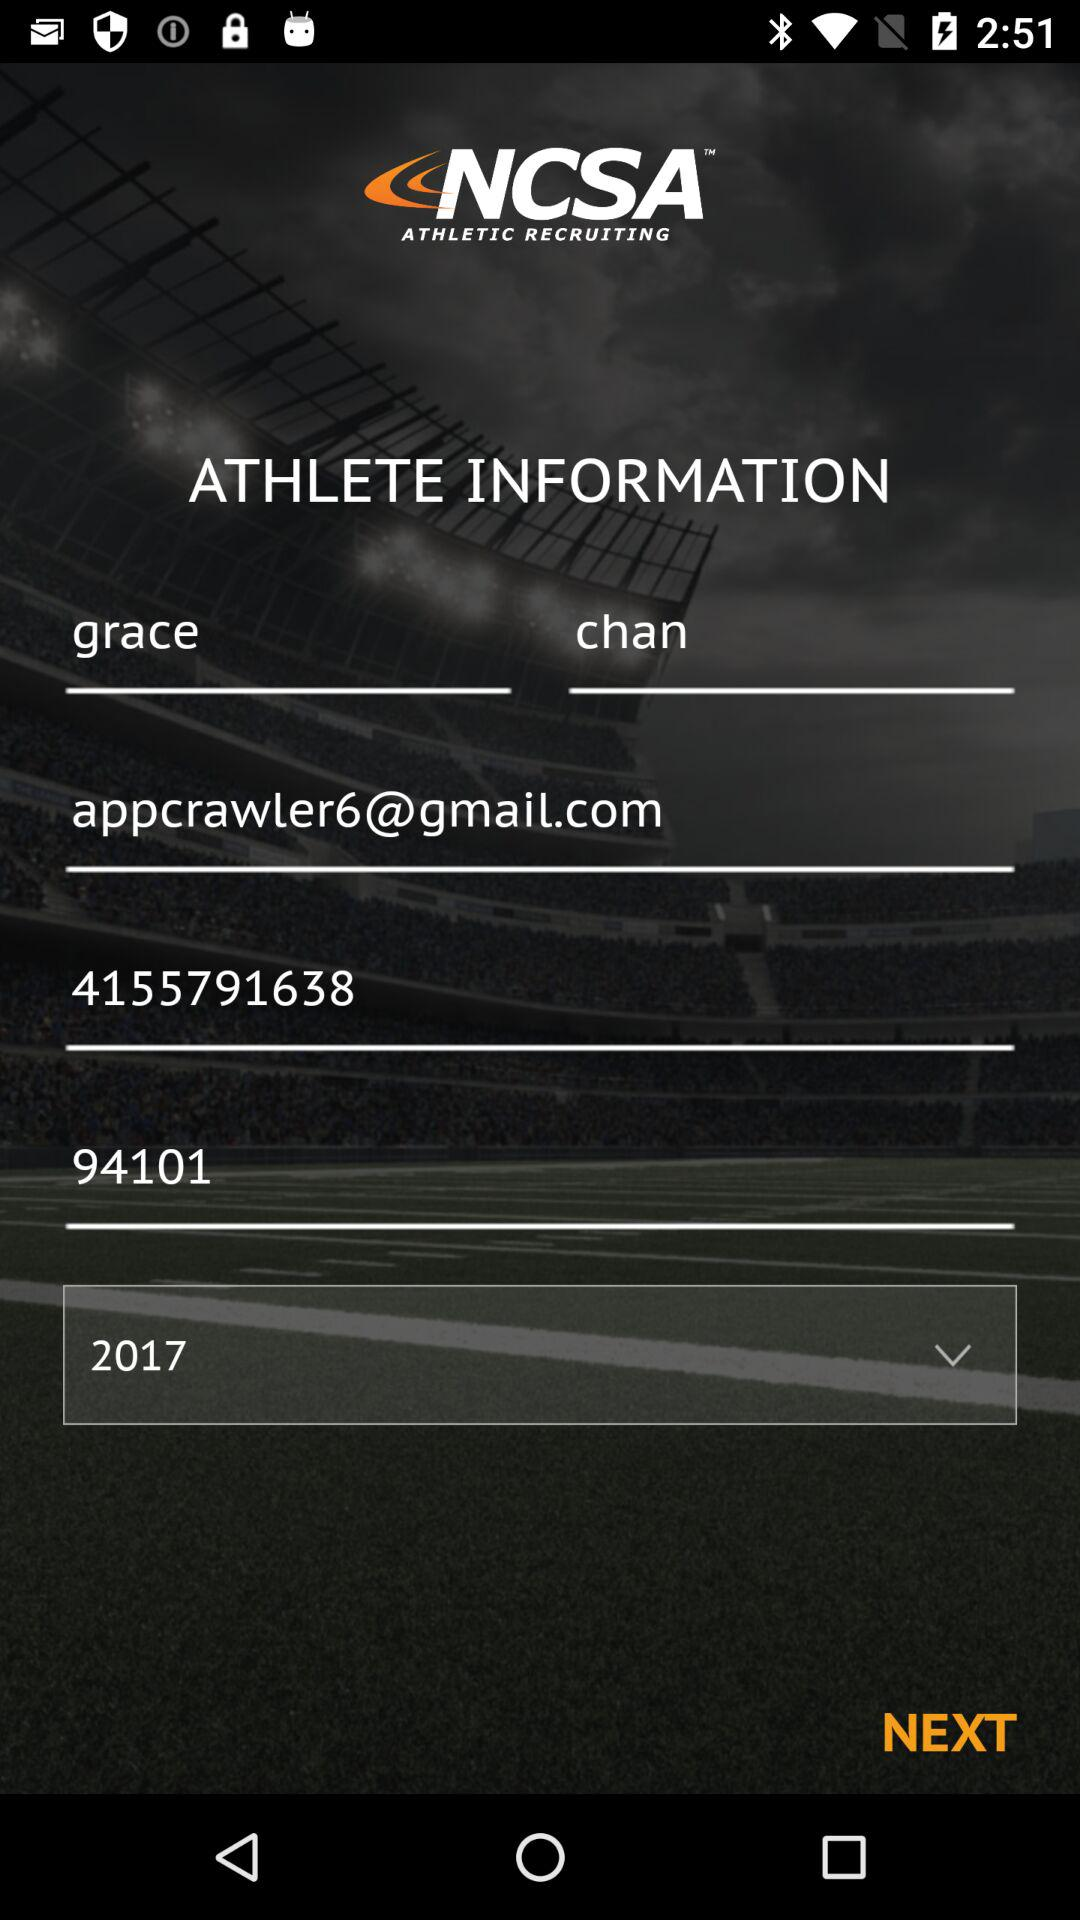What is the phone number of Grace? The phone number of Grace is 4155791638. 